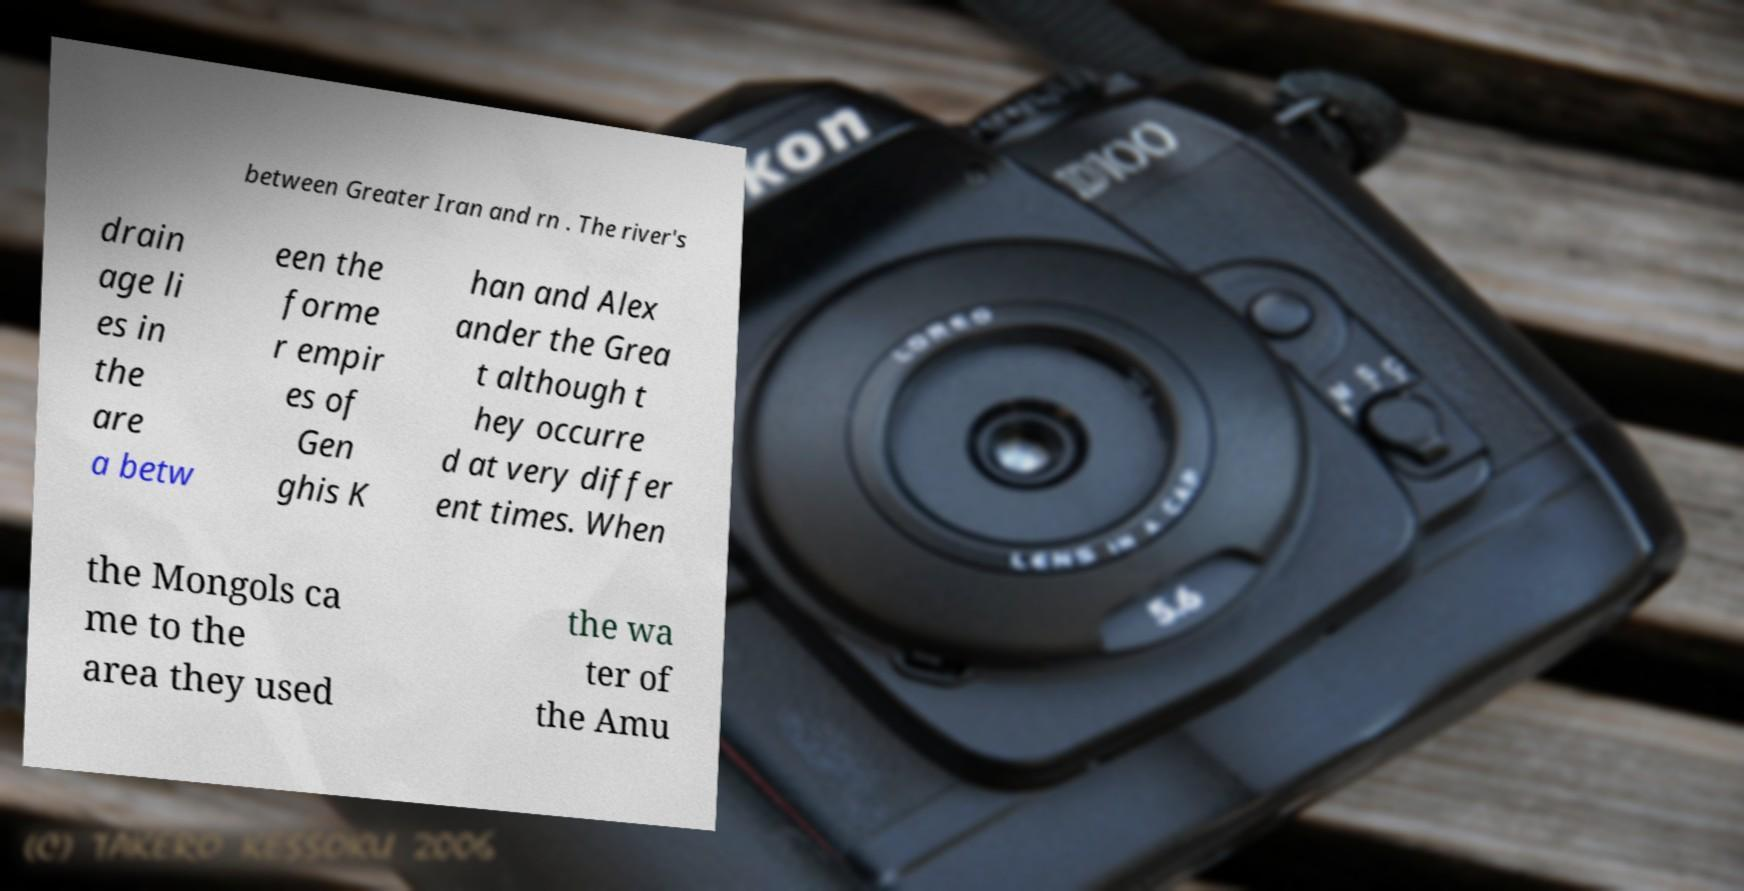Please identify and transcribe the text found in this image. between Greater Iran and rn . The river's drain age li es in the are a betw een the forme r empir es of Gen ghis K han and Alex ander the Grea t although t hey occurre d at very differ ent times. When the Mongols ca me to the area they used the wa ter of the Amu 